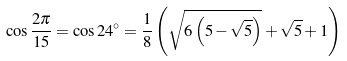<formula> <loc_0><loc_0><loc_500><loc_500>\cos { \frac { 2 \pi } { 1 5 } } = \cos 2 4 ^ { \circ } = { \frac { 1 } { 8 } } \left ( { \sqrt { 6 \left ( 5 - { \sqrt { 5 } } \right ) } } + { \sqrt { 5 } } + 1 \right )</formula> 